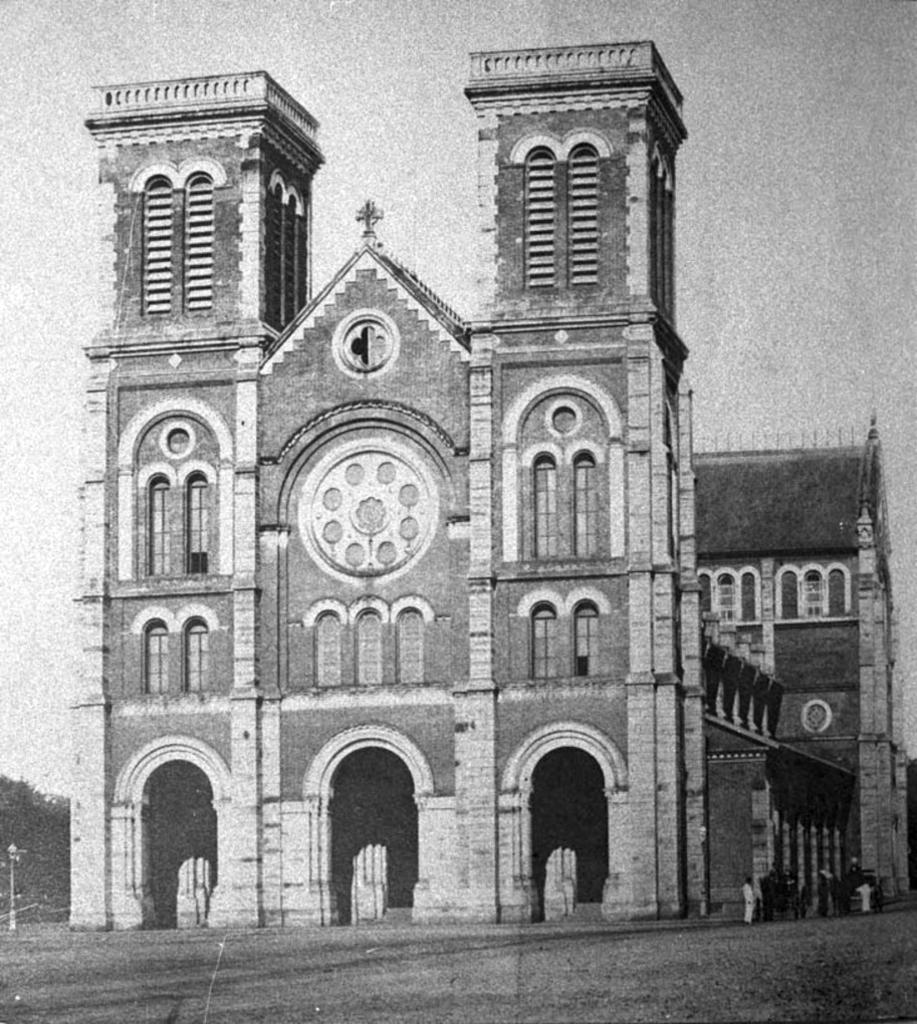Describe this image in one or two sentences. This is a black and white image. In the middle of the image there is a building. At the bottom, I can see the ground. On the left side there are few trees and a pole. At the top of the image I can see the sky. 